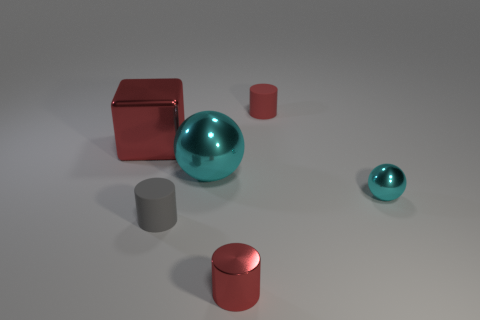Is there anything else that has the same shape as the tiny cyan shiny thing?
Offer a very short reply. Yes. What number of red objects are both behind the big shiny ball and in front of the red matte object?
Your answer should be very brief. 1. What is the material of the gray thing?
Ensure brevity in your answer.  Rubber. Are there an equal number of red shiny cubes right of the large metal cube and tiny red things?
Give a very brief answer. No. How many small cyan shiny objects are the same shape as the large cyan metallic thing?
Offer a very short reply. 1. Is the shape of the big cyan metallic object the same as the tiny cyan object?
Make the answer very short. Yes. How many objects are tiny shiny objects in front of the small cyan thing or matte cylinders?
Provide a short and direct response. 3. What is the shape of the red metal object behind the tiny red cylinder that is in front of the cylinder to the right of the metal cylinder?
Provide a succinct answer. Cube. There is a cyan object that is made of the same material as the big cyan ball; what shape is it?
Offer a very short reply. Sphere. What size is the shiny block?
Provide a short and direct response. Large. 